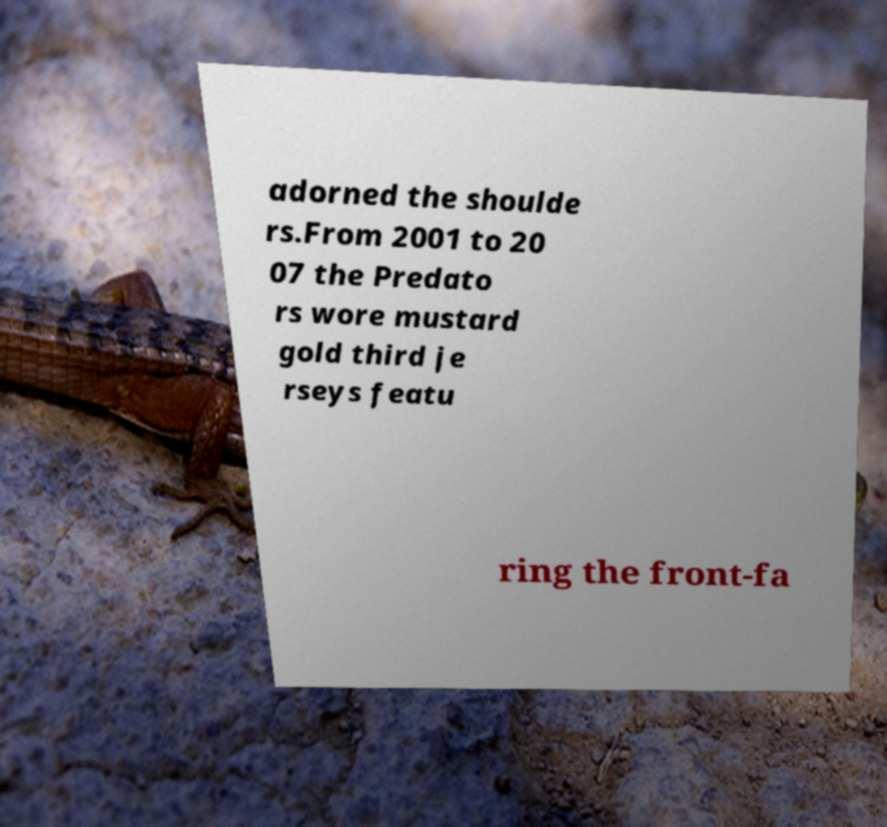What messages or text are displayed in this image? I need them in a readable, typed format. adorned the shoulde rs.From 2001 to 20 07 the Predato rs wore mustard gold third je rseys featu ring the front-fa 